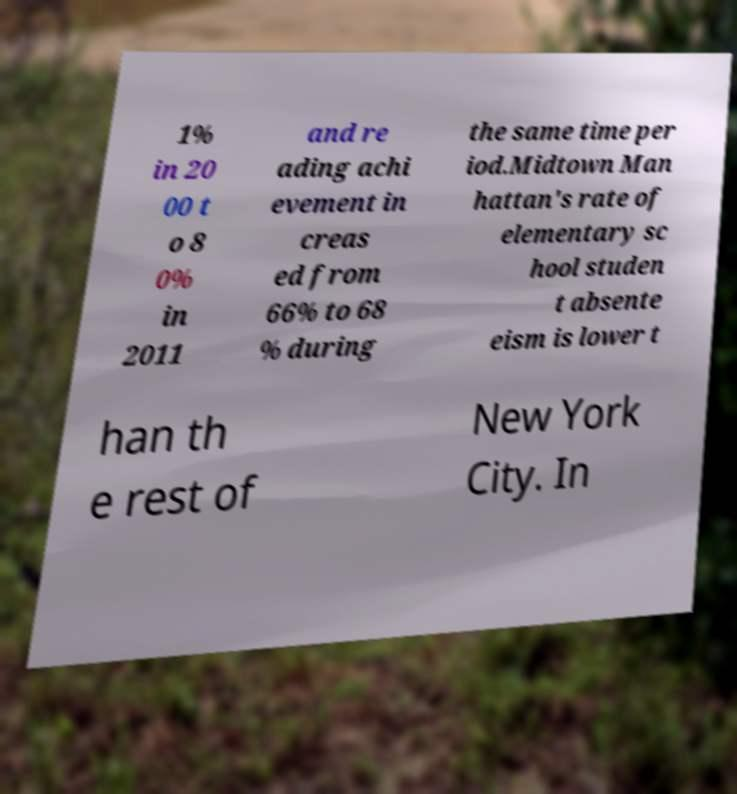Please identify and transcribe the text found in this image. 1% in 20 00 t o 8 0% in 2011 and re ading achi evement in creas ed from 66% to 68 % during the same time per iod.Midtown Man hattan's rate of elementary sc hool studen t absente eism is lower t han th e rest of New York City. In 